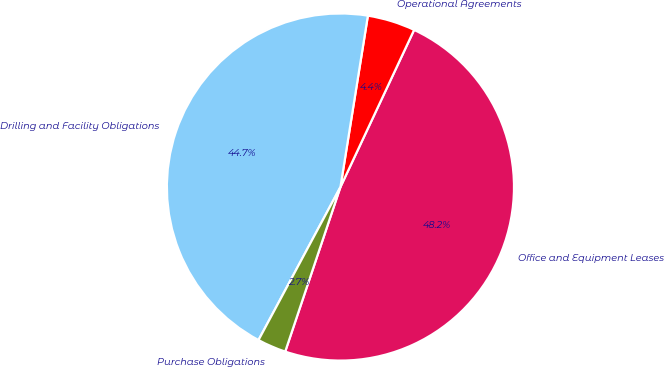Convert chart to OTSL. <chart><loc_0><loc_0><loc_500><loc_500><pie_chart><fcel>Office and Equipment Leases<fcel>Operational Agreements<fcel>Drilling and Facility Obligations<fcel>Purchase Obligations<nl><fcel>48.18%<fcel>4.45%<fcel>44.71%<fcel>2.67%<nl></chart> 